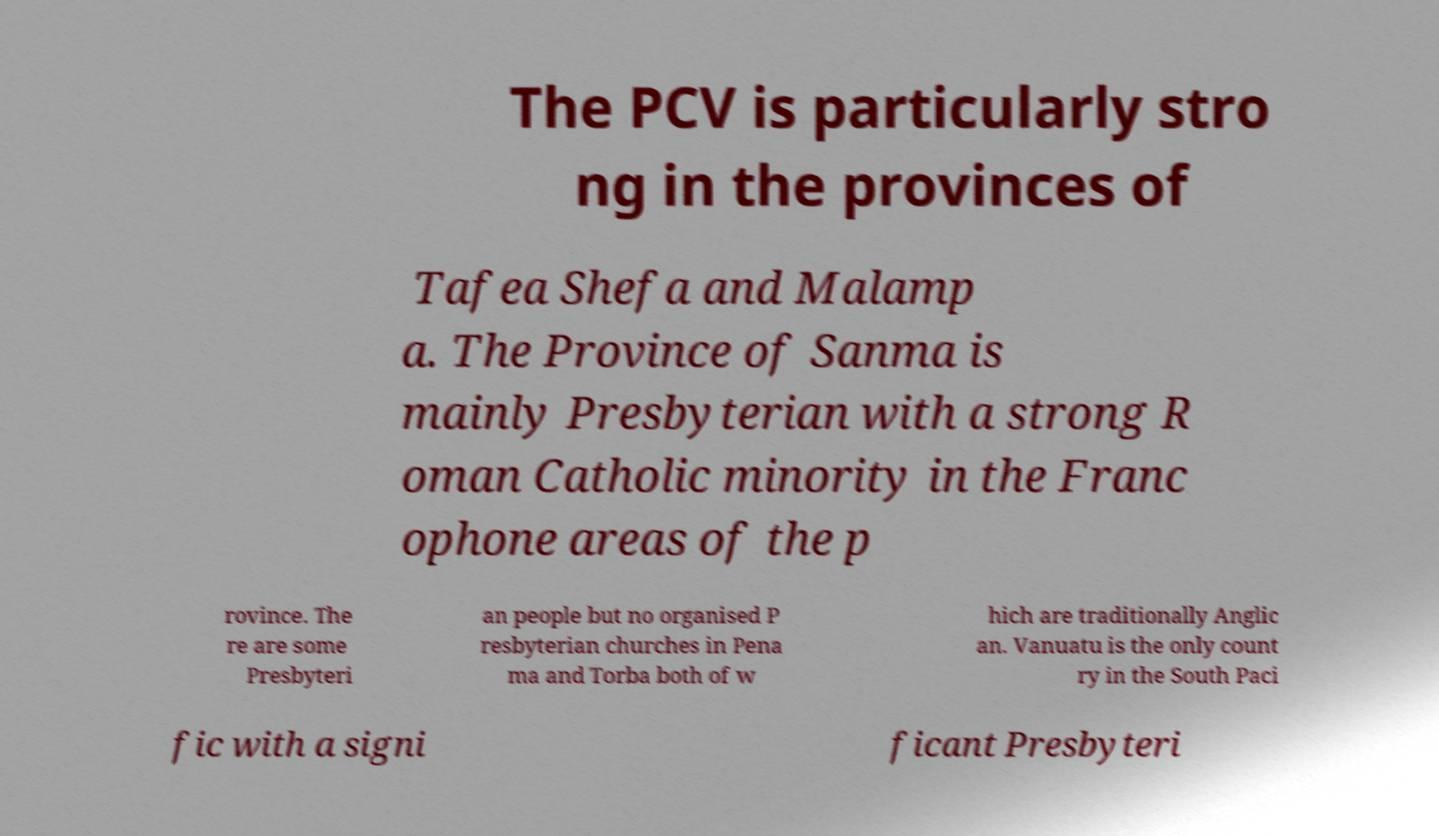Please read and relay the text visible in this image. What does it say? The PCV is particularly stro ng in the provinces of Tafea Shefa and Malamp a. The Province of Sanma is mainly Presbyterian with a strong R oman Catholic minority in the Franc ophone areas of the p rovince. The re are some Presbyteri an people but no organised P resbyterian churches in Pena ma and Torba both of w hich are traditionally Anglic an. Vanuatu is the only count ry in the South Paci fic with a signi ficant Presbyteri 